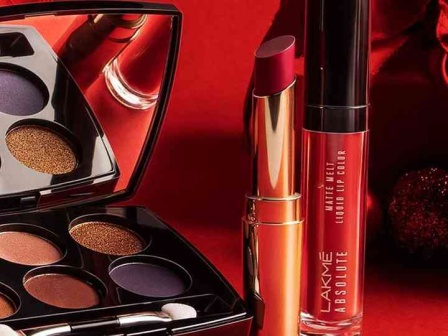Describe a possible scenario where these makeup products might be used in a reality TV show challenge. In the latest season of the hit reality TV show 'Beauty Battle Royale,' contestants are put to the ultimate test of creativity and skill. For this week's challenge, the makeup artists are tasked with creating a bold and glamorous evening look using only the products from the Lakme line displayed. The eyeshadow palette with its golden and royal purple hues is perfect for crafting a dramatic smokey eye. Contestants must use the metallic orange lipstick to draw attention to the lips, while the deep red liquid lip color can be either worn as intended or repurposed to create intricate designs on the face or body. The challenge pushes the contestants to think outside the box while showcasing their makeup artistry under time constraints. Judging criteria include originality, technique, and the overall impact of the look. The stakes are high, and the results promise to be nothing short of spectacular. 
Can you give a brief scenario where these makeup products might be found in someone's daily routine? In a daily routine, these Lakme products might be found on the vanity of someone who loves to experiment with makeup. Each morning, she reaches for the versatile eyeshadow palette to add a touch of gold or purple to her eyelids, depending on her outfit and mood. The metallic orange lipstick becomes her go-to for a cheerful daytime look, while the deep red liquid lip color is reserved for evening outings or important meetings where she wants to make a lasting impression. Each product seamlessly integrates into her routine, making it easy to transition from a fresh daytime look to a more dramatic evening appearance. 